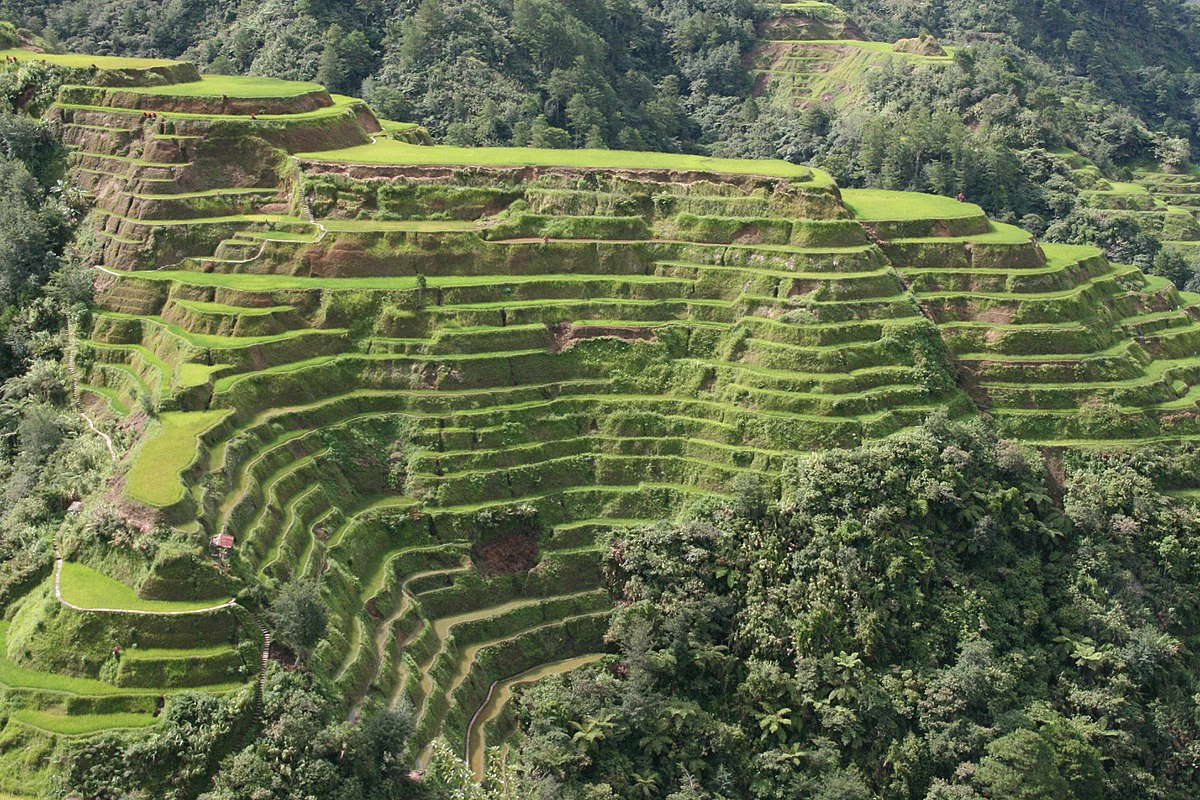What are the key elements in this picture? The image excellently captures the intricate beauty of the Banaue Rice Terraces in the Philippines, a celebrated UNESCO World Heritage Site. These terraces are carved into the mountainside with utmost precision, showcasing a brilliant green hue that highlights their lush fertility. These steps, formed from earth, stand as a testament to the advanced agricultural techniques of the Ifugao people, who developed this sustainable farming method over 2000 years ago. From this aerial perspective, one can admire the expansive swaths of terraces woven seamlessly into the natural landscape, encompassed by dense tropical greenery, which enriches the air and supports the local biodiversity. This image not only displays an agricultural wonder but also reflects a remarkable symbiosis between human ingenuity and the natural environment. 